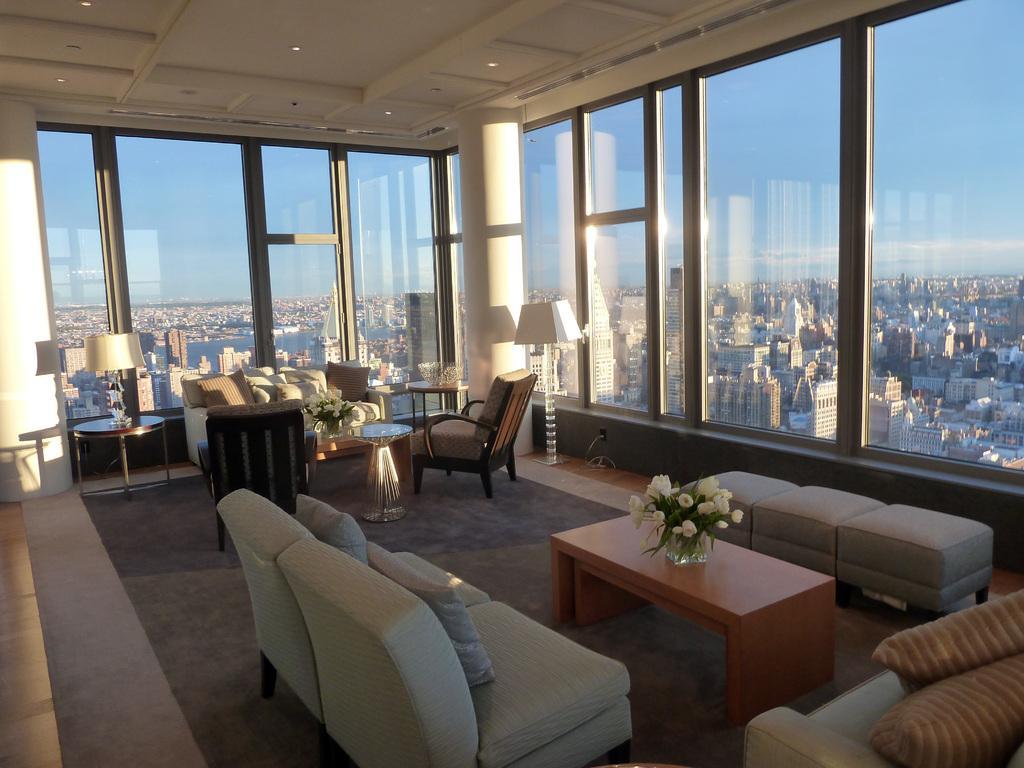In one or two sentences, can you explain what this image depicts? A living room with some furniture is shown in the picture. There is a sofa and two chairs with a table. There are two lamps beside the sofa. There are two sofa chairs,table and three cushion stools in the front. There is a glass frame work around the room. Through glass we can see the city. 